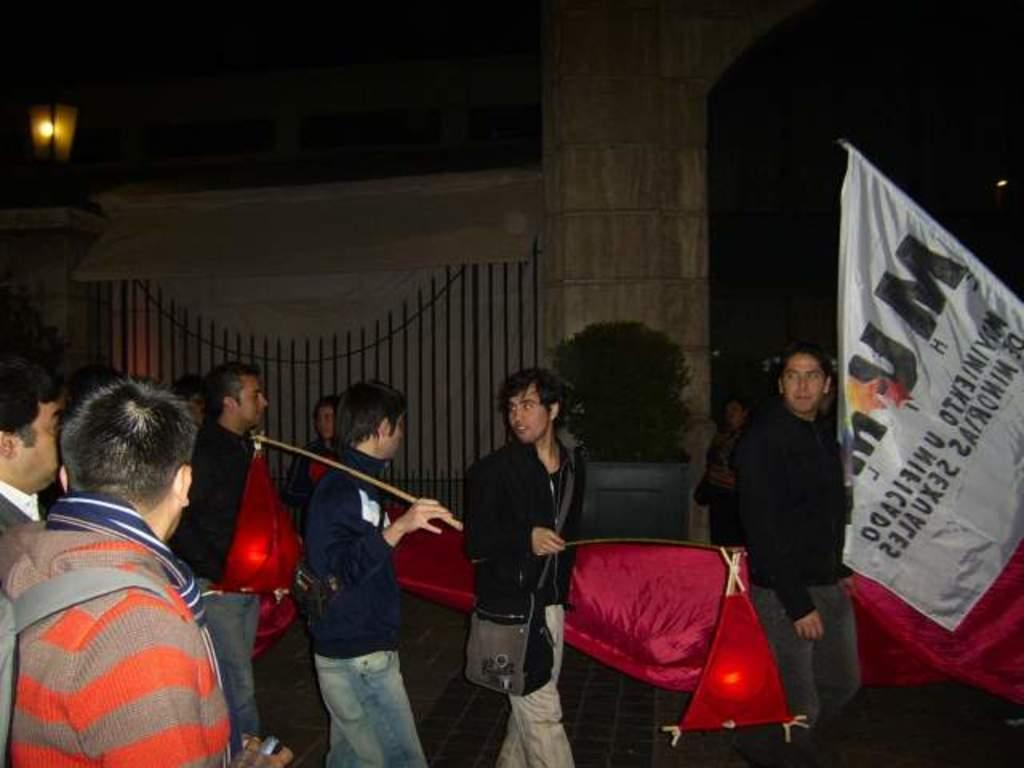What is happening with the group of people in the image? The people are walking in the image. What can be seen on the right side of the image? There is a white banner on the right side of the image. What is visible in the backdrop of the image? There is a fence in the backdrop of the image. Can you describe a specific object in the image? There is a pillar with a light in the image. What color crayon is being used to draw on the fence in the image? There is no crayon or drawing on the fence in the image. Is there a ring on any of the people's fingers in the image? The image does not show any rings on the people's fingers. 